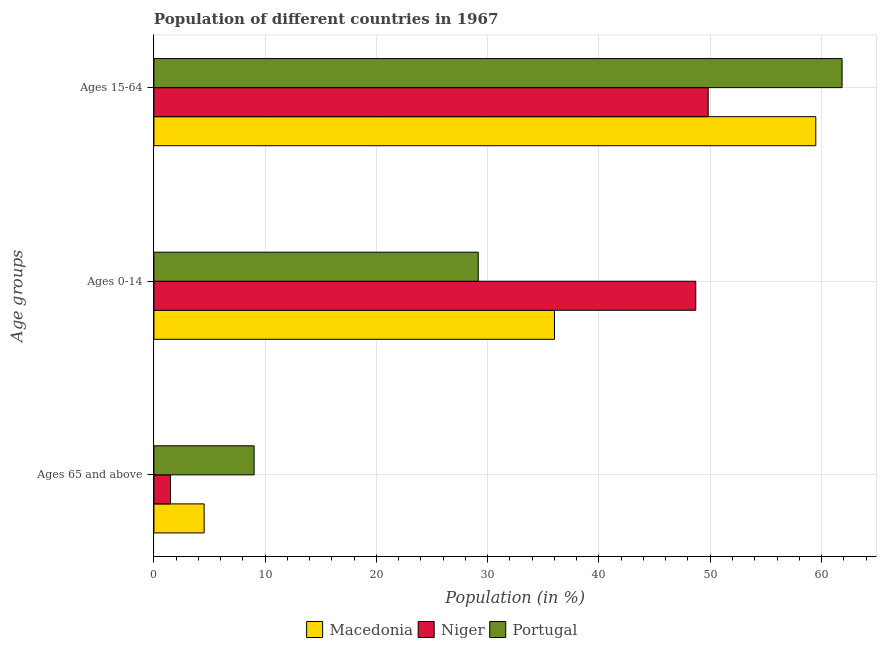How many groups of bars are there?
Your answer should be compact. 3. Are the number of bars per tick equal to the number of legend labels?
Give a very brief answer. Yes. Are the number of bars on each tick of the Y-axis equal?
Your response must be concise. Yes. What is the label of the 1st group of bars from the top?
Make the answer very short. Ages 15-64. What is the percentage of population within the age-group 0-14 in Portugal?
Your response must be concise. 29.15. Across all countries, what is the maximum percentage of population within the age-group of 65 and above?
Keep it short and to the point. 9. Across all countries, what is the minimum percentage of population within the age-group of 65 and above?
Offer a very short reply. 1.49. In which country was the percentage of population within the age-group of 65 and above maximum?
Your answer should be very brief. Portugal. In which country was the percentage of population within the age-group 15-64 minimum?
Give a very brief answer. Niger. What is the total percentage of population within the age-group of 65 and above in the graph?
Offer a very short reply. 15. What is the difference between the percentage of population within the age-group of 65 and above in Portugal and that in Macedonia?
Your answer should be compact. 4.49. What is the difference between the percentage of population within the age-group 15-64 in Niger and the percentage of population within the age-group 0-14 in Macedonia?
Make the answer very short. 13.82. What is the average percentage of population within the age-group 15-64 per country?
Your response must be concise. 57.05. What is the difference between the percentage of population within the age-group of 65 and above and percentage of population within the age-group 0-14 in Niger?
Provide a succinct answer. -47.21. What is the ratio of the percentage of population within the age-group 0-14 in Niger to that in Macedonia?
Provide a short and direct response. 1.35. Is the percentage of population within the age-group 15-64 in Niger less than that in Portugal?
Offer a very short reply. Yes. Is the difference between the percentage of population within the age-group 0-14 in Niger and Portugal greater than the difference between the percentage of population within the age-group of 65 and above in Niger and Portugal?
Your answer should be very brief. Yes. What is the difference between the highest and the second highest percentage of population within the age-group 15-64?
Make the answer very short. 2.36. What is the difference between the highest and the lowest percentage of population within the age-group 0-14?
Your response must be concise. 19.55. Is the sum of the percentage of population within the age-group 15-64 in Portugal and Macedonia greater than the maximum percentage of population within the age-group 0-14 across all countries?
Offer a terse response. Yes. What does the 2nd bar from the top in Ages 0-14 represents?
Your answer should be very brief. Niger. What does the 3rd bar from the bottom in Ages 65 and above represents?
Your answer should be compact. Portugal. How many bars are there?
Keep it short and to the point. 9. Are all the bars in the graph horizontal?
Ensure brevity in your answer.  Yes. Where does the legend appear in the graph?
Ensure brevity in your answer.  Bottom center. How are the legend labels stacked?
Offer a terse response. Horizontal. What is the title of the graph?
Provide a succinct answer. Population of different countries in 1967. What is the label or title of the Y-axis?
Offer a terse response. Age groups. What is the Population (in %) of Macedonia in Ages 65 and above?
Ensure brevity in your answer.  4.51. What is the Population (in %) in Niger in Ages 65 and above?
Keep it short and to the point. 1.49. What is the Population (in %) in Portugal in Ages 65 and above?
Your answer should be compact. 9. What is the Population (in %) in Macedonia in Ages 0-14?
Provide a succinct answer. 36. What is the Population (in %) of Niger in Ages 0-14?
Your answer should be compact. 48.7. What is the Population (in %) of Portugal in Ages 0-14?
Your answer should be very brief. 29.15. What is the Population (in %) of Macedonia in Ages 15-64?
Keep it short and to the point. 59.49. What is the Population (in %) of Niger in Ages 15-64?
Keep it short and to the point. 49.82. What is the Population (in %) in Portugal in Ages 15-64?
Offer a very short reply. 61.85. Across all Age groups, what is the maximum Population (in %) in Macedonia?
Keep it short and to the point. 59.49. Across all Age groups, what is the maximum Population (in %) in Niger?
Offer a very short reply. 49.82. Across all Age groups, what is the maximum Population (in %) of Portugal?
Ensure brevity in your answer.  61.85. Across all Age groups, what is the minimum Population (in %) in Macedonia?
Provide a short and direct response. 4.51. Across all Age groups, what is the minimum Population (in %) in Niger?
Give a very brief answer. 1.49. Across all Age groups, what is the minimum Population (in %) in Portugal?
Give a very brief answer. 9. What is the total Population (in %) in Macedonia in the graph?
Offer a very short reply. 100. What is the total Population (in %) in Niger in the graph?
Your response must be concise. 100. What is the total Population (in %) of Portugal in the graph?
Ensure brevity in your answer.  100. What is the difference between the Population (in %) of Macedonia in Ages 65 and above and that in Ages 0-14?
Offer a very short reply. -31.49. What is the difference between the Population (in %) in Niger in Ages 65 and above and that in Ages 0-14?
Your answer should be very brief. -47.21. What is the difference between the Population (in %) in Portugal in Ages 65 and above and that in Ages 0-14?
Keep it short and to the point. -20.14. What is the difference between the Population (in %) in Macedonia in Ages 65 and above and that in Ages 15-64?
Your answer should be very brief. -54.97. What is the difference between the Population (in %) in Niger in Ages 65 and above and that in Ages 15-64?
Provide a short and direct response. -48.33. What is the difference between the Population (in %) in Portugal in Ages 65 and above and that in Ages 15-64?
Provide a short and direct response. -52.85. What is the difference between the Population (in %) in Macedonia in Ages 0-14 and that in Ages 15-64?
Provide a short and direct response. -23.49. What is the difference between the Population (in %) in Niger in Ages 0-14 and that in Ages 15-64?
Your answer should be compact. -1.12. What is the difference between the Population (in %) of Portugal in Ages 0-14 and that in Ages 15-64?
Your answer should be compact. -32.7. What is the difference between the Population (in %) in Macedonia in Ages 65 and above and the Population (in %) in Niger in Ages 0-14?
Ensure brevity in your answer.  -44.19. What is the difference between the Population (in %) in Macedonia in Ages 65 and above and the Population (in %) in Portugal in Ages 0-14?
Ensure brevity in your answer.  -24.63. What is the difference between the Population (in %) of Niger in Ages 65 and above and the Population (in %) of Portugal in Ages 0-14?
Ensure brevity in your answer.  -27.66. What is the difference between the Population (in %) in Macedonia in Ages 65 and above and the Population (in %) in Niger in Ages 15-64?
Your response must be concise. -45.3. What is the difference between the Population (in %) of Macedonia in Ages 65 and above and the Population (in %) of Portugal in Ages 15-64?
Ensure brevity in your answer.  -57.34. What is the difference between the Population (in %) of Niger in Ages 65 and above and the Population (in %) of Portugal in Ages 15-64?
Make the answer very short. -60.36. What is the difference between the Population (in %) in Macedonia in Ages 0-14 and the Population (in %) in Niger in Ages 15-64?
Provide a succinct answer. -13.81. What is the difference between the Population (in %) in Macedonia in Ages 0-14 and the Population (in %) in Portugal in Ages 15-64?
Give a very brief answer. -25.85. What is the difference between the Population (in %) of Niger in Ages 0-14 and the Population (in %) of Portugal in Ages 15-64?
Your answer should be very brief. -13.15. What is the average Population (in %) in Macedonia per Age groups?
Your response must be concise. 33.33. What is the average Population (in %) of Niger per Age groups?
Offer a very short reply. 33.33. What is the average Population (in %) of Portugal per Age groups?
Provide a succinct answer. 33.33. What is the difference between the Population (in %) in Macedonia and Population (in %) in Niger in Ages 65 and above?
Offer a very short reply. 3.03. What is the difference between the Population (in %) of Macedonia and Population (in %) of Portugal in Ages 65 and above?
Make the answer very short. -4.49. What is the difference between the Population (in %) in Niger and Population (in %) in Portugal in Ages 65 and above?
Your answer should be very brief. -7.52. What is the difference between the Population (in %) in Macedonia and Population (in %) in Niger in Ages 0-14?
Your answer should be very brief. -12.7. What is the difference between the Population (in %) in Macedonia and Population (in %) in Portugal in Ages 0-14?
Ensure brevity in your answer.  6.85. What is the difference between the Population (in %) in Niger and Population (in %) in Portugal in Ages 0-14?
Offer a terse response. 19.55. What is the difference between the Population (in %) in Macedonia and Population (in %) in Niger in Ages 15-64?
Provide a short and direct response. 9.67. What is the difference between the Population (in %) in Macedonia and Population (in %) in Portugal in Ages 15-64?
Your response must be concise. -2.36. What is the difference between the Population (in %) in Niger and Population (in %) in Portugal in Ages 15-64?
Provide a short and direct response. -12.03. What is the ratio of the Population (in %) of Macedonia in Ages 65 and above to that in Ages 0-14?
Your response must be concise. 0.13. What is the ratio of the Population (in %) of Niger in Ages 65 and above to that in Ages 0-14?
Your answer should be very brief. 0.03. What is the ratio of the Population (in %) in Portugal in Ages 65 and above to that in Ages 0-14?
Your answer should be very brief. 0.31. What is the ratio of the Population (in %) in Macedonia in Ages 65 and above to that in Ages 15-64?
Provide a short and direct response. 0.08. What is the ratio of the Population (in %) in Niger in Ages 65 and above to that in Ages 15-64?
Ensure brevity in your answer.  0.03. What is the ratio of the Population (in %) of Portugal in Ages 65 and above to that in Ages 15-64?
Provide a short and direct response. 0.15. What is the ratio of the Population (in %) in Macedonia in Ages 0-14 to that in Ages 15-64?
Ensure brevity in your answer.  0.61. What is the ratio of the Population (in %) in Niger in Ages 0-14 to that in Ages 15-64?
Give a very brief answer. 0.98. What is the ratio of the Population (in %) of Portugal in Ages 0-14 to that in Ages 15-64?
Make the answer very short. 0.47. What is the difference between the highest and the second highest Population (in %) in Macedonia?
Offer a very short reply. 23.49. What is the difference between the highest and the second highest Population (in %) of Niger?
Ensure brevity in your answer.  1.12. What is the difference between the highest and the second highest Population (in %) in Portugal?
Your response must be concise. 32.7. What is the difference between the highest and the lowest Population (in %) of Macedonia?
Give a very brief answer. 54.97. What is the difference between the highest and the lowest Population (in %) of Niger?
Offer a terse response. 48.33. What is the difference between the highest and the lowest Population (in %) of Portugal?
Ensure brevity in your answer.  52.85. 